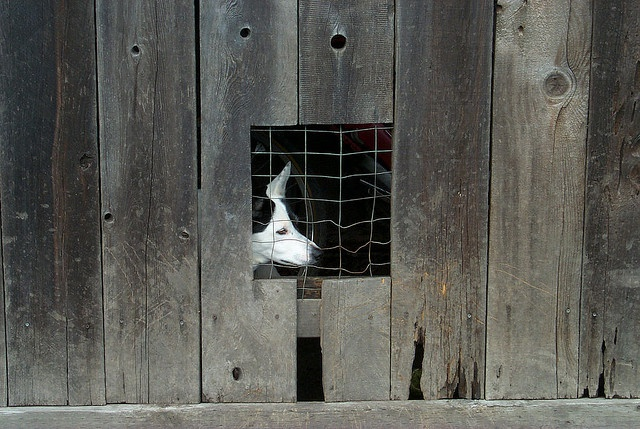Describe the objects in this image and their specific colors. I can see a dog in purple, lightgray, black, darkgray, and gray tones in this image. 